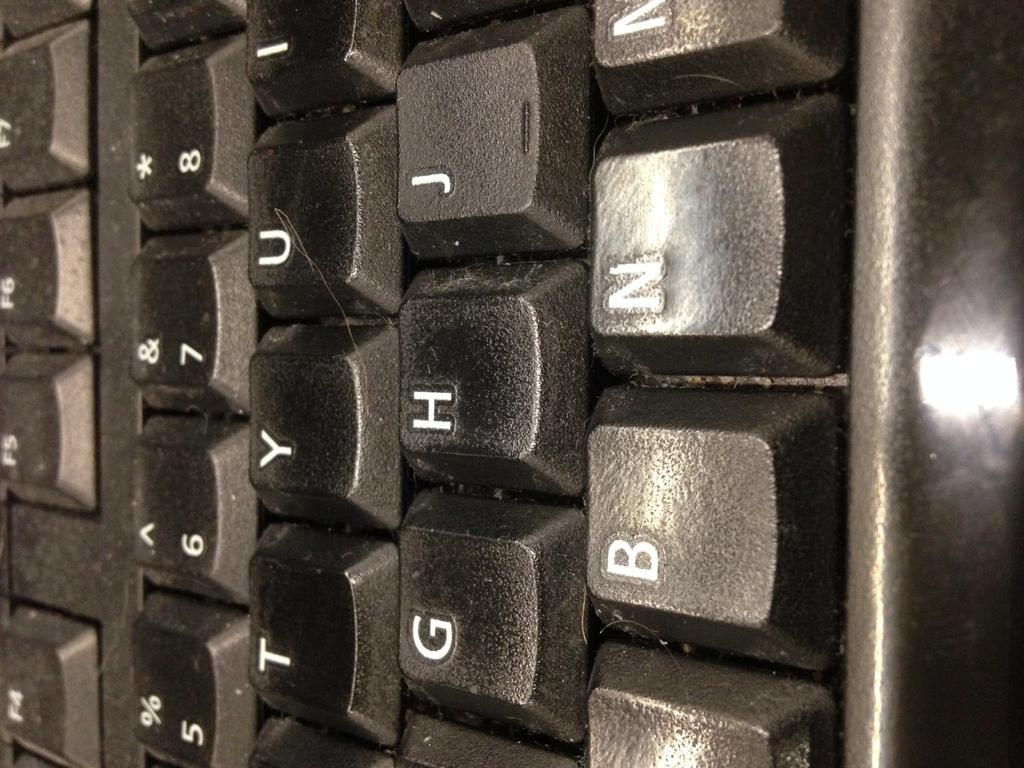<image>
Present a compact description of the photo's key features. the keyboard letter key buttons of g,h, j , t and y 